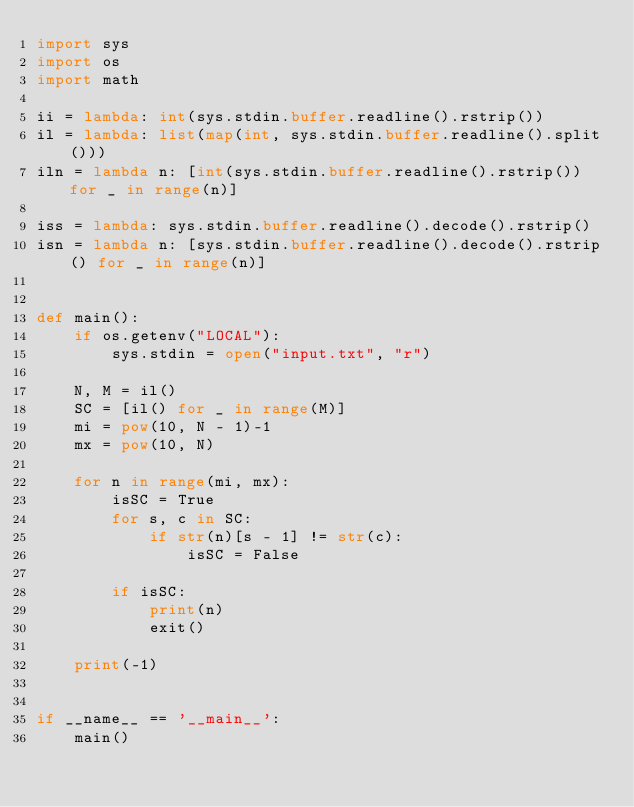<code> <loc_0><loc_0><loc_500><loc_500><_Python_>import sys
import os
import math

ii = lambda: int(sys.stdin.buffer.readline().rstrip())
il = lambda: list(map(int, sys.stdin.buffer.readline().split()))
iln = lambda n: [int(sys.stdin.buffer.readline().rstrip()) for _ in range(n)]

iss = lambda: sys.stdin.buffer.readline().decode().rstrip()
isn = lambda n: [sys.stdin.buffer.readline().decode().rstrip() for _ in range(n)]


def main():
    if os.getenv("LOCAL"):
        sys.stdin = open("input.txt", "r")

    N, M = il()
    SC = [il() for _ in range(M)]
    mi = pow(10, N - 1)-1
    mx = pow(10, N)

    for n in range(mi, mx):
        isSC = True
        for s, c in SC:
            if str(n)[s - 1] != str(c):
                isSC = False

        if isSC:
            print(n)
            exit()

    print(-1)


if __name__ == '__main__':
    main()
</code> 